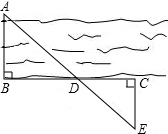First perform reasoning, then finally select the question from the choices in the following format: Answer: xxx.
Question: In order to estimate the width of the river, we can select a target on the opposite bank of the river and mark it as point A, and then select points B and C on this side of the river so that AB ⊥ BC, and then select point E on the river bank. Let EC ⊥ BC, suppose BC and AE intersect at point D, as shown in the figure, measured BD = 120.0, DC = 60.0, EC = u, then the approximate width of the river is 100.0
 What is the value of the unknown variable u?
Choices:
A: 66.0
B: 50.0
C: 42.0
D: 37.0  Given that the approximate width of the river is 100 meters and BD = 120, DC = 60, and EC = u. In triangle ADB, by the Pythagorean theorem, we have AB^2 = AD^2 + BD^2. Substituting the given values, we get AB^2 = AD^2 + 120^2. In triangle EDC, by the Pythagorean theorem, we have EC^2 = ED^2 + DC^2. Substituting the given values, we get u^2 = ED^2 + 60^2. Since AD = ED (they are the same line segment), we can equate AB^2 and u^2, resulting in AD^2 + 120^2 = AD^2 + 60^2. Simplifying this equation, we get 14400 = 3600. Solving for u, we find that u = 50. Therefore, the value of the unknown variable u is 50.  Therefore, the answer is option B.
Answer:B 